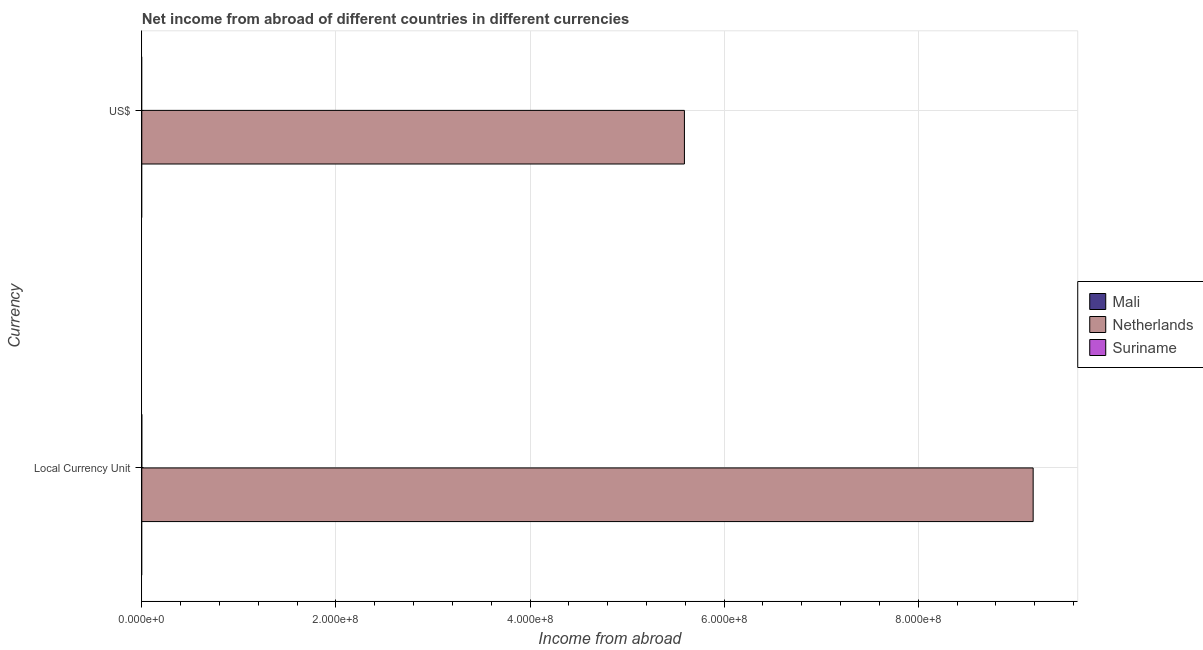Are the number of bars per tick equal to the number of legend labels?
Offer a very short reply. No. What is the label of the 2nd group of bars from the top?
Provide a succinct answer. Local Currency Unit. What is the income from abroad in us$ in Mali?
Your response must be concise. 0. Across all countries, what is the maximum income from abroad in us$?
Your answer should be very brief. 5.59e+08. Across all countries, what is the minimum income from abroad in us$?
Give a very brief answer. 0. In which country was the income from abroad in us$ maximum?
Make the answer very short. Netherlands. What is the total income from abroad in us$ in the graph?
Provide a short and direct response. 5.59e+08. What is the average income from abroad in us$ per country?
Your response must be concise. 1.86e+08. What is the difference between the income from abroad in constant 2005 us$ and income from abroad in us$ in Netherlands?
Your answer should be compact. 3.59e+08. In how many countries, is the income from abroad in us$ greater than 600000000 units?
Make the answer very short. 0. In how many countries, is the income from abroad in us$ greater than the average income from abroad in us$ taken over all countries?
Provide a short and direct response. 1. How many countries are there in the graph?
Ensure brevity in your answer.  3. What is the difference between two consecutive major ticks on the X-axis?
Make the answer very short. 2.00e+08. How many legend labels are there?
Give a very brief answer. 3. What is the title of the graph?
Ensure brevity in your answer.  Net income from abroad of different countries in different currencies. What is the label or title of the X-axis?
Ensure brevity in your answer.  Income from abroad. What is the label or title of the Y-axis?
Make the answer very short. Currency. What is the Income from abroad of Netherlands in Local Currency Unit?
Provide a succinct answer. 9.18e+08. What is the Income from abroad of Suriname in Local Currency Unit?
Your response must be concise. 0. What is the Income from abroad in Mali in US$?
Your response must be concise. 0. What is the Income from abroad in Netherlands in US$?
Your answer should be compact. 5.59e+08. Across all Currency, what is the maximum Income from abroad in Netherlands?
Offer a very short reply. 9.18e+08. Across all Currency, what is the minimum Income from abroad in Netherlands?
Provide a short and direct response. 5.59e+08. What is the total Income from abroad of Mali in the graph?
Offer a terse response. 0. What is the total Income from abroad in Netherlands in the graph?
Your response must be concise. 1.48e+09. What is the total Income from abroad of Suriname in the graph?
Offer a very short reply. 0. What is the difference between the Income from abroad in Netherlands in Local Currency Unit and that in US$?
Make the answer very short. 3.59e+08. What is the average Income from abroad of Netherlands per Currency?
Ensure brevity in your answer.  7.39e+08. What is the ratio of the Income from abroad in Netherlands in Local Currency Unit to that in US$?
Ensure brevity in your answer.  1.64. What is the difference between the highest and the second highest Income from abroad in Netherlands?
Ensure brevity in your answer.  3.59e+08. What is the difference between the highest and the lowest Income from abroad of Netherlands?
Provide a short and direct response. 3.59e+08. 